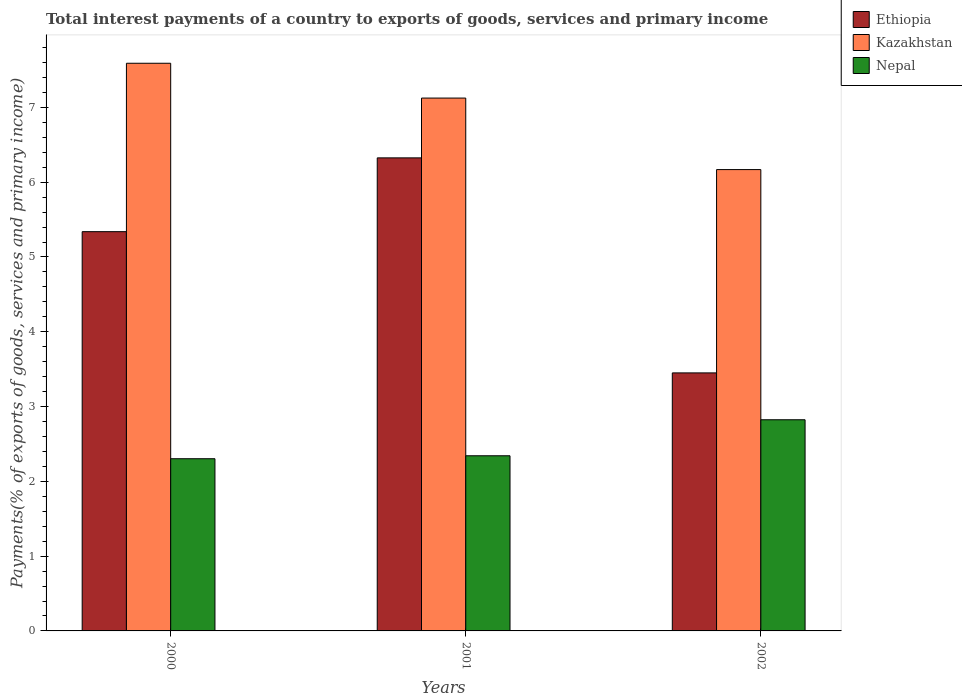How many groups of bars are there?
Provide a short and direct response. 3. Are the number of bars per tick equal to the number of legend labels?
Keep it short and to the point. Yes. How many bars are there on the 1st tick from the left?
Provide a short and direct response. 3. What is the label of the 1st group of bars from the left?
Keep it short and to the point. 2000. What is the total interest payments in Kazakhstan in 2001?
Provide a succinct answer. 7.12. Across all years, what is the maximum total interest payments in Nepal?
Make the answer very short. 2.82. Across all years, what is the minimum total interest payments in Kazakhstan?
Provide a succinct answer. 6.17. What is the total total interest payments in Ethiopia in the graph?
Provide a short and direct response. 15.11. What is the difference between the total interest payments in Ethiopia in 2000 and that in 2002?
Give a very brief answer. 1.89. What is the difference between the total interest payments in Nepal in 2000 and the total interest payments in Ethiopia in 2002?
Give a very brief answer. -1.15. What is the average total interest payments in Nepal per year?
Your answer should be compact. 2.49. In the year 2000, what is the difference between the total interest payments in Nepal and total interest payments in Ethiopia?
Give a very brief answer. -3.04. What is the ratio of the total interest payments in Nepal in 2000 to that in 2002?
Provide a short and direct response. 0.82. Is the total interest payments in Nepal in 2000 less than that in 2001?
Offer a very short reply. Yes. Is the difference between the total interest payments in Nepal in 2000 and 2001 greater than the difference between the total interest payments in Ethiopia in 2000 and 2001?
Keep it short and to the point. Yes. What is the difference between the highest and the second highest total interest payments in Ethiopia?
Your response must be concise. 0.99. What is the difference between the highest and the lowest total interest payments in Kazakhstan?
Your answer should be compact. 1.42. In how many years, is the total interest payments in Ethiopia greater than the average total interest payments in Ethiopia taken over all years?
Ensure brevity in your answer.  2. What does the 1st bar from the left in 2002 represents?
Ensure brevity in your answer.  Ethiopia. What does the 1st bar from the right in 2001 represents?
Make the answer very short. Nepal. Is it the case that in every year, the sum of the total interest payments in Kazakhstan and total interest payments in Nepal is greater than the total interest payments in Ethiopia?
Offer a terse response. Yes. How many bars are there?
Your answer should be compact. 9. Are all the bars in the graph horizontal?
Keep it short and to the point. No. How many years are there in the graph?
Offer a terse response. 3. What is the difference between two consecutive major ticks on the Y-axis?
Provide a succinct answer. 1. Does the graph contain any zero values?
Provide a short and direct response. No. Where does the legend appear in the graph?
Keep it short and to the point. Top right. How are the legend labels stacked?
Keep it short and to the point. Vertical. What is the title of the graph?
Provide a short and direct response. Total interest payments of a country to exports of goods, services and primary income. Does "India" appear as one of the legend labels in the graph?
Keep it short and to the point. No. What is the label or title of the X-axis?
Make the answer very short. Years. What is the label or title of the Y-axis?
Your answer should be compact. Payments(% of exports of goods, services and primary income). What is the Payments(% of exports of goods, services and primary income) of Ethiopia in 2000?
Give a very brief answer. 5.34. What is the Payments(% of exports of goods, services and primary income) of Kazakhstan in 2000?
Offer a very short reply. 7.59. What is the Payments(% of exports of goods, services and primary income) in Nepal in 2000?
Your answer should be very brief. 2.3. What is the Payments(% of exports of goods, services and primary income) in Ethiopia in 2001?
Your answer should be compact. 6.32. What is the Payments(% of exports of goods, services and primary income) in Kazakhstan in 2001?
Offer a terse response. 7.12. What is the Payments(% of exports of goods, services and primary income) in Nepal in 2001?
Provide a short and direct response. 2.34. What is the Payments(% of exports of goods, services and primary income) in Ethiopia in 2002?
Provide a short and direct response. 3.45. What is the Payments(% of exports of goods, services and primary income) in Kazakhstan in 2002?
Your answer should be compact. 6.17. What is the Payments(% of exports of goods, services and primary income) in Nepal in 2002?
Your answer should be very brief. 2.82. Across all years, what is the maximum Payments(% of exports of goods, services and primary income) of Ethiopia?
Give a very brief answer. 6.32. Across all years, what is the maximum Payments(% of exports of goods, services and primary income) in Kazakhstan?
Offer a terse response. 7.59. Across all years, what is the maximum Payments(% of exports of goods, services and primary income) of Nepal?
Your answer should be very brief. 2.82. Across all years, what is the minimum Payments(% of exports of goods, services and primary income) in Ethiopia?
Ensure brevity in your answer.  3.45. Across all years, what is the minimum Payments(% of exports of goods, services and primary income) in Kazakhstan?
Your answer should be very brief. 6.17. Across all years, what is the minimum Payments(% of exports of goods, services and primary income) in Nepal?
Keep it short and to the point. 2.3. What is the total Payments(% of exports of goods, services and primary income) of Ethiopia in the graph?
Ensure brevity in your answer.  15.11. What is the total Payments(% of exports of goods, services and primary income) of Kazakhstan in the graph?
Your response must be concise. 20.88. What is the total Payments(% of exports of goods, services and primary income) in Nepal in the graph?
Your answer should be very brief. 7.47. What is the difference between the Payments(% of exports of goods, services and primary income) in Ethiopia in 2000 and that in 2001?
Ensure brevity in your answer.  -0.99. What is the difference between the Payments(% of exports of goods, services and primary income) of Kazakhstan in 2000 and that in 2001?
Your response must be concise. 0.47. What is the difference between the Payments(% of exports of goods, services and primary income) in Nepal in 2000 and that in 2001?
Provide a short and direct response. -0.04. What is the difference between the Payments(% of exports of goods, services and primary income) in Ethiopia in 2000 and that in 2002?
Give a very brief answer. 1.89. What is the difference between the Payments(% of exports of goods, services and primary income) in Kazakhstan in 2000 and that in 2002?
Offer a very short reply. 1.42. What is the difference between the Payments(% of exports of goods, services and primary income) in Nepal in 2000 and that in 2002?
Make the answer very short. -0.52. What is the difference between the Payments(% of exports of goods, services and primary income) in Ethiopia in 2001 and that in 2002?
Your answer should be very brief. 2.88. What is the difference between the Payments(% of exports of goods, services and primary income) of Kazakhstan in 2001 and that in 2002?
Make the answer very short. 0.96. What is the difference between the Payments(% of exports of goods, services and primary income) in Nepal in 2001 and that in 2002?
Offer a very short reply. -0.48. What is the difference between the Payments(% of exports of goods, services and primary income) of Ethiopia in 2000 and the Payments(% of exports of goods, services and primary income) of Kazakhstan in 2001?
Provide a succinct answer. -1.79. What is the difference between the Payments(% of exports of goods, services and primary income) of Ethiopia in 2000 and the Payments(% of exports of goods, services and primary income) of Nepal in 2001?
Offer a terse response. 3. What is the difference between the Payments(% of exports of goods, services and primary income) in Kazakhstan in 2000 and the Payments(% of exports of goods, services and primary income) in Nepal in 2001?
Provide a short and direct response. 5.25. What is the difference between the Payments(% of exports of goods, services and primary income) of Ethiopia in 2000 and the Payments(% of exports of goods, services and primary income) of Kazakhstan in 2002?
Offer a very short reply. -0.83. What is the difference between the Payments(% of exports of goods, services and primary income) in Ethiopia in 2000 and the Payments(% of exports of goods, services and primary income) in Nepal in 2002?
Make the answer very short. 2.51. What is the difference between the Payments(% of exports of goods, services and primary income) in Kazakhstan in 2000 and the Payments(% of exports of goods, services and primary income) in Nepal in 2002?
Make the answer very short. 4.77. What is the difference between the Payments(% of exports of goods, services and primary income) in Ethiopia in 2001 and the Payments(% of exports of goods, services and primary income) in Kazakhstan in 2002?
Ensure brevity in your answer.  0.16. What is the difference between the Payments(% of exports of goods, services and primary income) in Ethiopia in 2001 and the Payments(% of exports of goods, services and primary income) in Nepal in 2002?
Ensure brevity in your answer.  3.5. What is the difference between the Payments(% of exports of goods, services and primary income) in Kazakhstan in 2001 and the Payments(% of exports of goods, services and primary income) in Nepal in 2002?
Provide a short and direct response. 4.3. What is the average Payments(% of exports of goods, services and primary income) of Ethiopia per year?
Provide a short and direct response. 5.04. What is the average Payments(% of exports of goods, services and primary income) of Kazakhstan per year?
Your answer should be very brief. 6.96. What is the average Payments(% of exports of goods, services and primary income) in Nepal per year?
Give a very brief answer. 2.49. In the year 2000, what is the difference between the Payments(% of exports of goods, services and primary income) in Ethiopia and Payments(% of exports of goods, services and primary income) in Kazakhstan?
Offer a terse response. -2.25. In the year 2000, what is the difference between the Payments(% of exports of goods, services and primary income) in Ethiopia and Payments(% of exports of goods, services and primary income) in Nepal?
Your answer should be very brief. 3.04. In the year 2000, what is the difference between the Payments(% of exports of goods, services and primary income) of Kazakhstan and Payments(% of exports of goods, services and primary income) of Nepal?
Your answer should be compact. 5.29. In the year 2001, what is the difference between the Payments(% of exports of goods, services and primary income) of Ethiopia and Payments(% of exports of goods, services and primary income) of Kazakhstan?
Offer a terse response. -0.8. In the year 2001, what is the difference between the Payments(% of exports of goods, services and primary income) of Ethiopia and Payments(% of exports of goods, services and primary income) of Nepal?
Make the answer very short. 3.98. In the year 2001, what is the difference between the Payments(% of exports of goods, services and primary income) in Kazakhstan and Payments(% of exports of goods, services and primary income) in Nepal?
Your answer should be compact. 4.78. In the year 2002, what is the difference between the Payments(% of exports of goods, services and primary income) of Ethiopia and Payments(% of exports of goods, services and primary income) of Kazakhstan?
Make the answer very short. -2.72. In the year 2002, what is the difference between the Payments(% of exports of goods, services and primary income) of Ethiopia and Payments(% of exports of goods, services and primary income) of Nepal?
Keep it short and to the point. 0.63. In the year 2002, what is the difference between the Payments(% of exports of goods, services and primary income) in Kazakhstan and Payments(% of exports of goods, services and primary income) in Nepal?
Keep it short and to the point. 3.34. What is the ratio of the Payments(% of exports of goods, services and primary income) of Ethiopia in 2000 to that in 2001?
Your answer should be compact. 0.84. What is the ratio of the Payments(% of exports of goods, services and primary income) in Kazakhstan in 2000 to that in 2001?
Provide a succinct answer. 1.07. What is the ratio of the Payments(% of exports of goods, services and primary income) of Nepal in 2000 to that in 2001?
Provide a short and direct response. 0.98. What is the ratio of the Payments(% of exports of goods, services and primary income) of Ethiopia in 2000 to that in 2002?
Your response must be concise. 1.55. What is the ratio of the Payments(% of exports of goods, services and primary income) of Kazakhstan in 2000 to that in 2002?
Your response must be concise. 1.23. What is the ratio of the Payments(% of exports of goods, services and primary income) of Nepal in 2000 to that in 2002?
Make the answer very short. 0.82. What is the ratio of the Payments(% of exports of goods, services and primary income) of Ethiopia in 2001 to that in 2002?
Make the answer very short. 1.83. What is the ratio of the Payments(% of exports of goods, services and primary income) of Kazakhstan in 2001 to that in 2002?
Offer a terse response. 1.16. What is the ratio of the Payments(% of exports of goods, services and primary income) in Nepal in 2001 to that in 2002?
Offer a terse response. 0.83. What is the difference between the highest and the second highest Payments(% of exports of goods, services and primary income) in Ethiopia?
Keep it short and to the point. 0.99. What is the difference between the highest and the second highest Payments(% of exports of goods, services and primary income) of Kazakhstan?
Keep it short and to the point. 0.47. What is the difference between the highest and the second highest Payments(% of exports of goods, services and primary income) in Nepal?
Provide a short and direct response. 0.48. What is the difference between the highest and the lowest Payments(% of exports of goods, services and primary income) in Ethiopia?
Offer a terse response. 2.88. What is the difference between the highest and the lowest Payments(% of exports of goods, services and primary income) of Kazakhstan?
Keep it short and to the point. 1.42. What is the difference between the highest and the lowest Payments(% of exports of goods, services and primary income) of Nepal?
Keep it short and to the point. 0.52. 